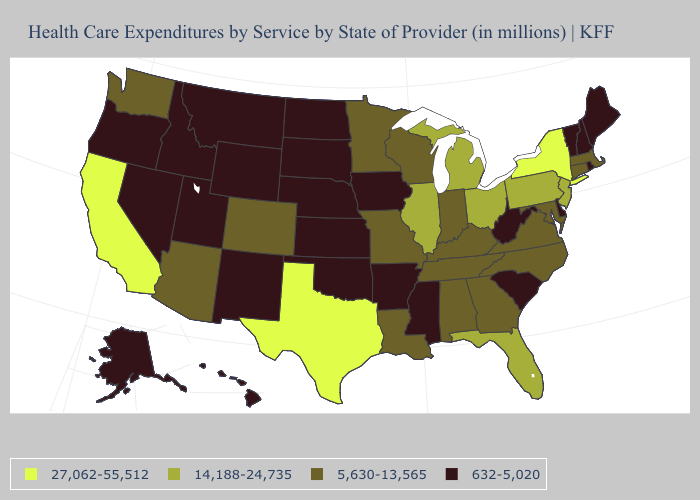Name the states that have a value in the range 5,630-13,565?
Give a very brief answer. Alabama, Arizona, Colorado, Connecticut, Georgia, Indiana, Kentucky, Louisiana, Maryland, Massachusetts, Minnesota, Missouri, North Carolina, Tennessee, Virginia, Washington, Wisconsin. What is the highest value in the Northeast ?
Keep it brief. 27,062-55,512. Name the states that have a value in the range 632-5,020?
Give a very brief answer. Alaska, Arkansas, Delaware, Hawaii, Idaho, Iowa, Kansas, Maine, Mississippi, Montana, Nebraska, Nevada, New Hampshire, New Mexico, North Dakota, Oklahoma, Oregon, Rhode Island, South Carolina, South Dakota, Utah, Vermont, West Virginia, Wyoming. What is the lowest value in the USA?
Give a very brief answer. 632-5,020. Name the states that have a value in the range 14,188-24,735?
Keep it brief. Florida, Illinois, Michigan, New Jersey, Ohio, Pennsylvania. Which states hav the highest value in the West?
Short answer required. California. Among the states that border Texas , does New Mexico have the lowest value?
Be succinct. Yes. What is the value of Alaska?
Concise answer only. 632-5,020. What is the value of Delaware?
Keep it brief. 632-5,020. Does Texas have the highest value in the South?
Keep it brief. Yes. What is the value of Rhode Island?
Keep it brief. 632-5,020. Name the states that have a value in the range 27,062-55,512?
Concise answer only. California, New York, Texas. Which states have the lowest value in the Northeast?
Answer briefly. Maine, New Hampshire, Rhode Island, Vermont. 